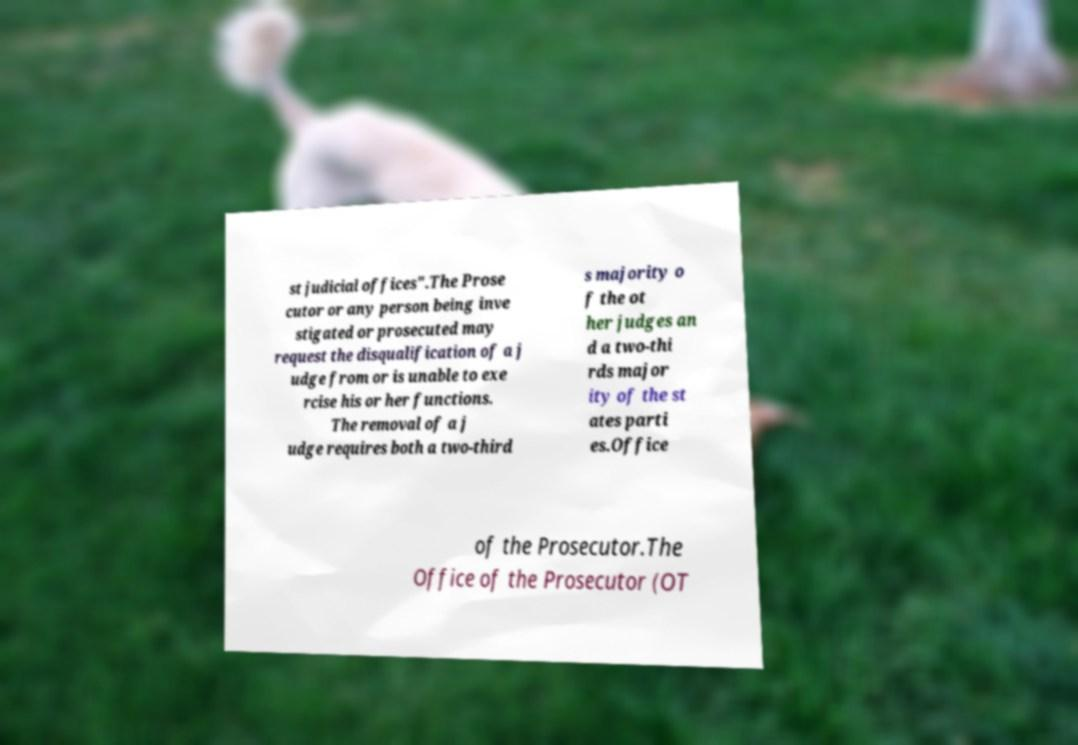Could you extract and type out the text from this image? st judicial offices".The Prose cutor or any person being inve stigated or prosecuted may request the disqualification of a j udge from or is unable to exe rcise his or her functions. The removal of a j udge requires both a two-third s majority o f the ot her judges an d a two-thi rds major ity of the st ates parti es.Office of the Prosecutor.The Office of the Prosecutor (OT 